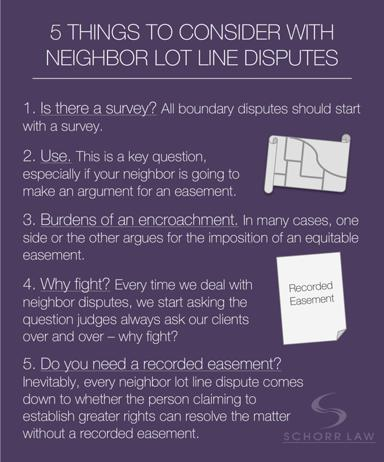What is the primary purpose of the document or text? The document serves as a critical informational guide aimed at elucidating the key considerations for anyone facing or involved in neighbor lot line disputes. It's designed to help understand each step of the dispute resolution process. 